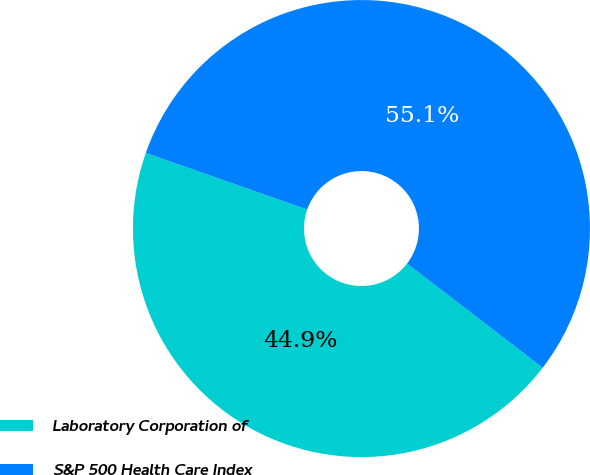Convert chart. <chart><loc_0><loc_0><loc_500><loc_500><pie_chart><fcel>Laboratory Corporation of<fcel>S&P 500 Health Care Index<nl><fcel>44.94%<fcel>55.06%<nl></chart> 